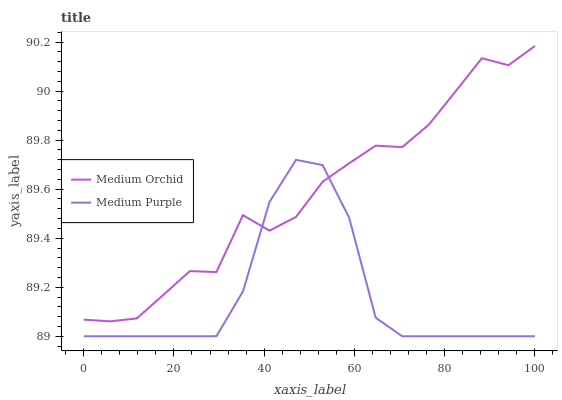Does Medium Purple have the minimum area under the curve?
Answer yes or no. Yes. Does Medium Orchid have the maximum area under the curve?
Answer yes or no. Yes. Does Medium Orchid have the minimum area under the curve?
Answer yes or no. No. Is Medium Orchid the smoothest?
Answer yes or no. Yes. Is Medium Purple the roughest?
Answer yes or no. Yes. Is Medium Orchid the roughest?
Answer yes or no. No. Does Medium Purple have the lowest value?
Answer yes or no. Yes. Does Medium Orchid have the lowest value?
Answer yes or no. No. Does Medium Orchid have the highest value?
Answer yes or no. Yes. Does Medium Purple intersect Medium Orchid?
Answer yes or no. Yes. Is Medium Purple less than Medium Orchid?
Answer yes or no. No. Is Medium Purple greater than Medium Orchid?
Answer yes or no. No. 